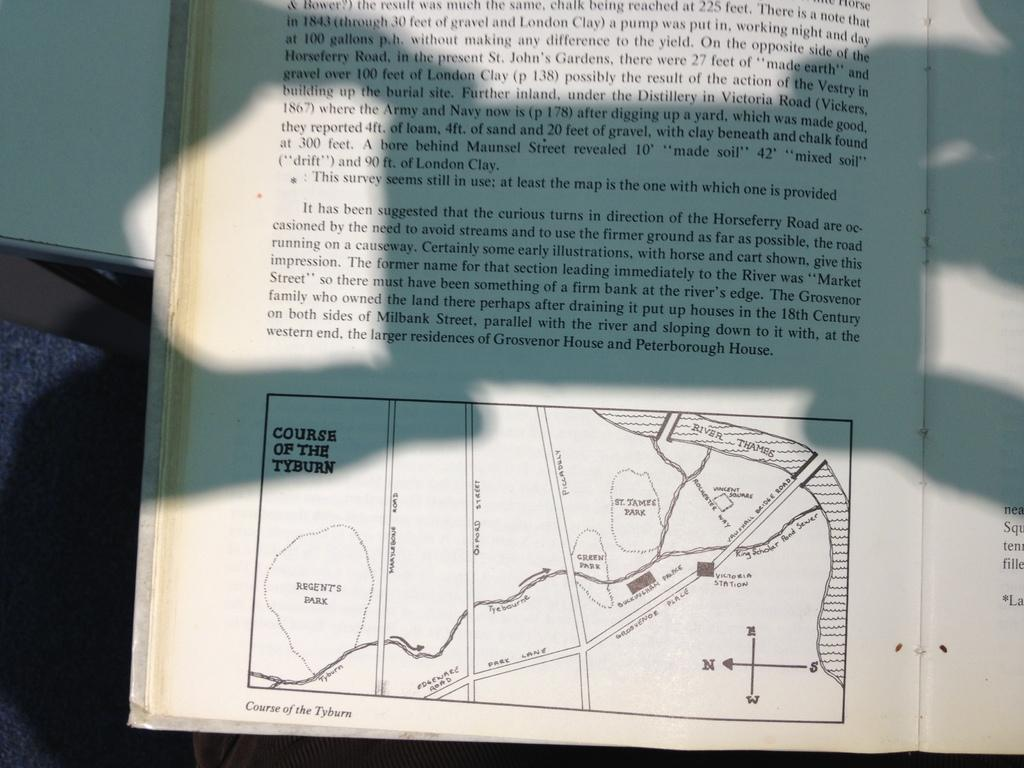What is present in the image that contains written information? There is text in a book in the image. What type of visual element can be found at the bottom of the image? There is a diagram in the bottom of the image. What type of brush is used to paint the text in the image? There is no brush present in the image, as the text is likely printed or handwritten in the book. 